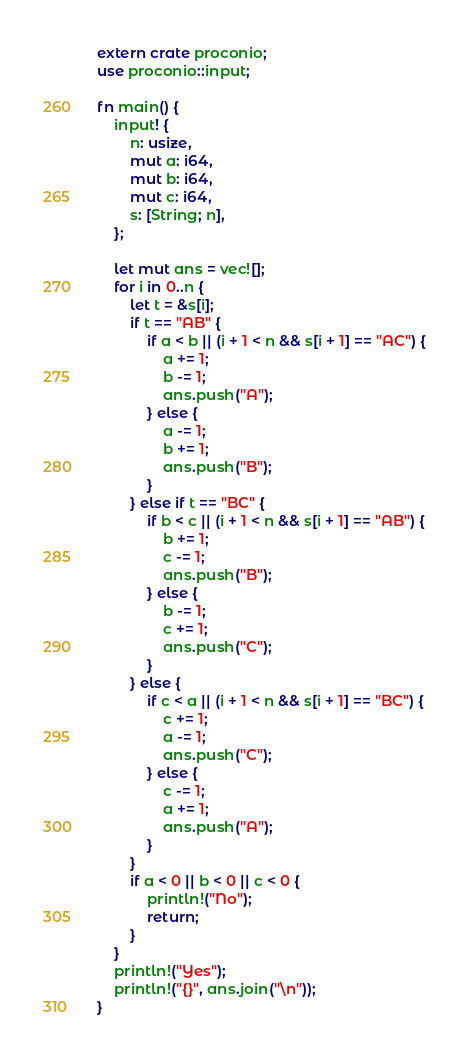Convert code to text. <code><loc_0><loc_0><loc_500><loc_500><_Rust_>extern crate proconio;
use proconio::input;

fn main() {
    input! {
        n: usize,
        mut a: i64,
        mut b: i64,
        mut c: i64,
        s: [String; n],
    };

    let mut ans = vec![];
    for i in 0..n {
        let t = &s[i];
        if t == "AB" {
            if a < b || (i + 1 < n && s[i + 1] == "AC") {
                a += 1;
                b -= 1;
                ans.push("A");
            } else {
                a -= 1;
                b += 1;
                ans.push("B");
            }
        } else if t == "BC" {
            if b < c || (i + 1 < n && s[i + 1] == "AB") {
                b += 1;
                c -= 1;
                ans.push("B");
            } else {
                b -= 1;
                c += 1;
                ans.push("C");
            }
        } else {
            if c < a || (i + 1 < n && s[i + 1] == "BC") {
                c += 1;
                a -= 1;
                ans.push("C");
            } else {
                c -= 1;
                a += 1;
                ans.push("A");
            }
        }
        if a < 0 || b < 0 || c < 0 {
            println!("No");
            return;
        }
    }
    println!("Yes");
    println!("{}", ans.join("\n"));
}
</code> 